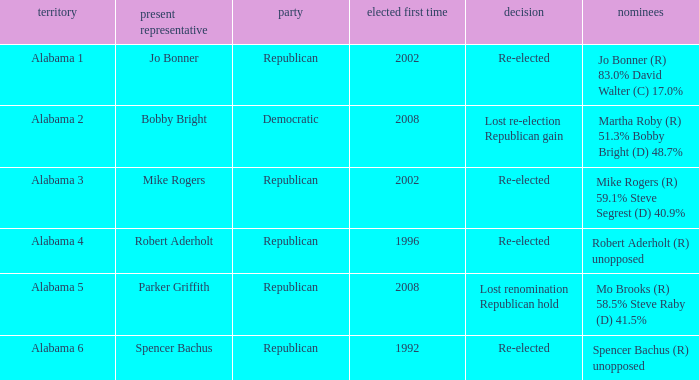Name the result for first elected being 1992 Re-elected. 